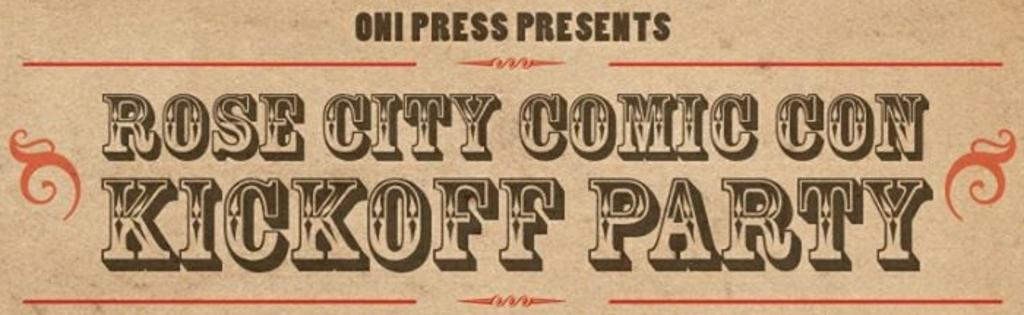What type of visual is the image? The image is a poster. What can be found on the poster? There is text on the poster. What type of farm is depicted on the poster? There is no farm depicted on the poster; it only contains text. What discovery is being made in the poster? There is no discovery being made in the poster; it only contains text. 